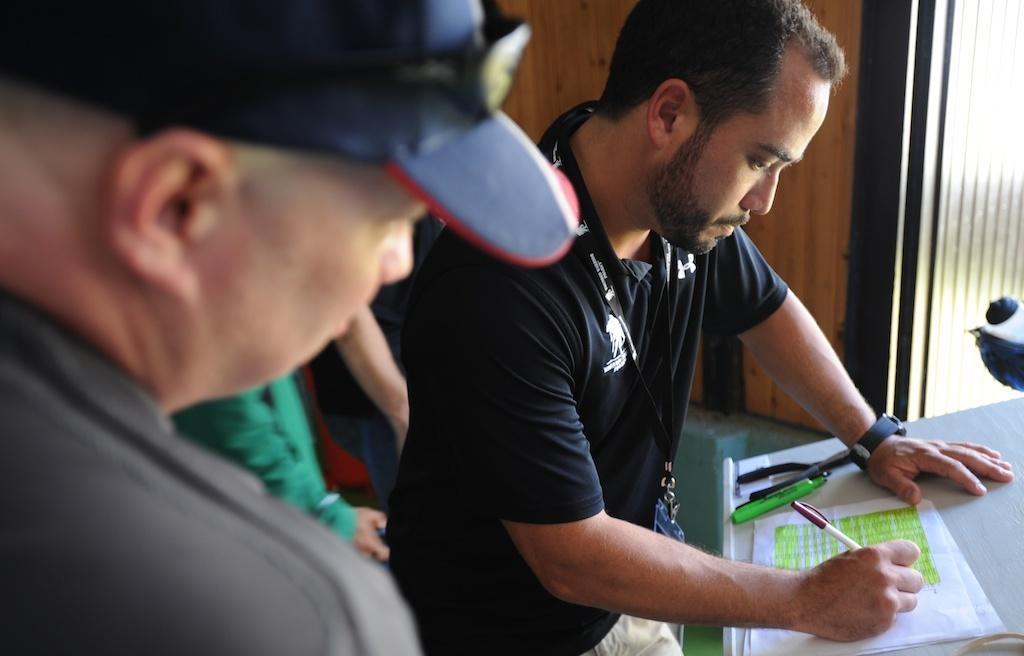How would you summarize this image in a sentence or two? In this image I can see there are few persons visible and I can see a person writing on paper kept his hand on the stand , in the stand I can see pens and I can see the wall on the right side. 